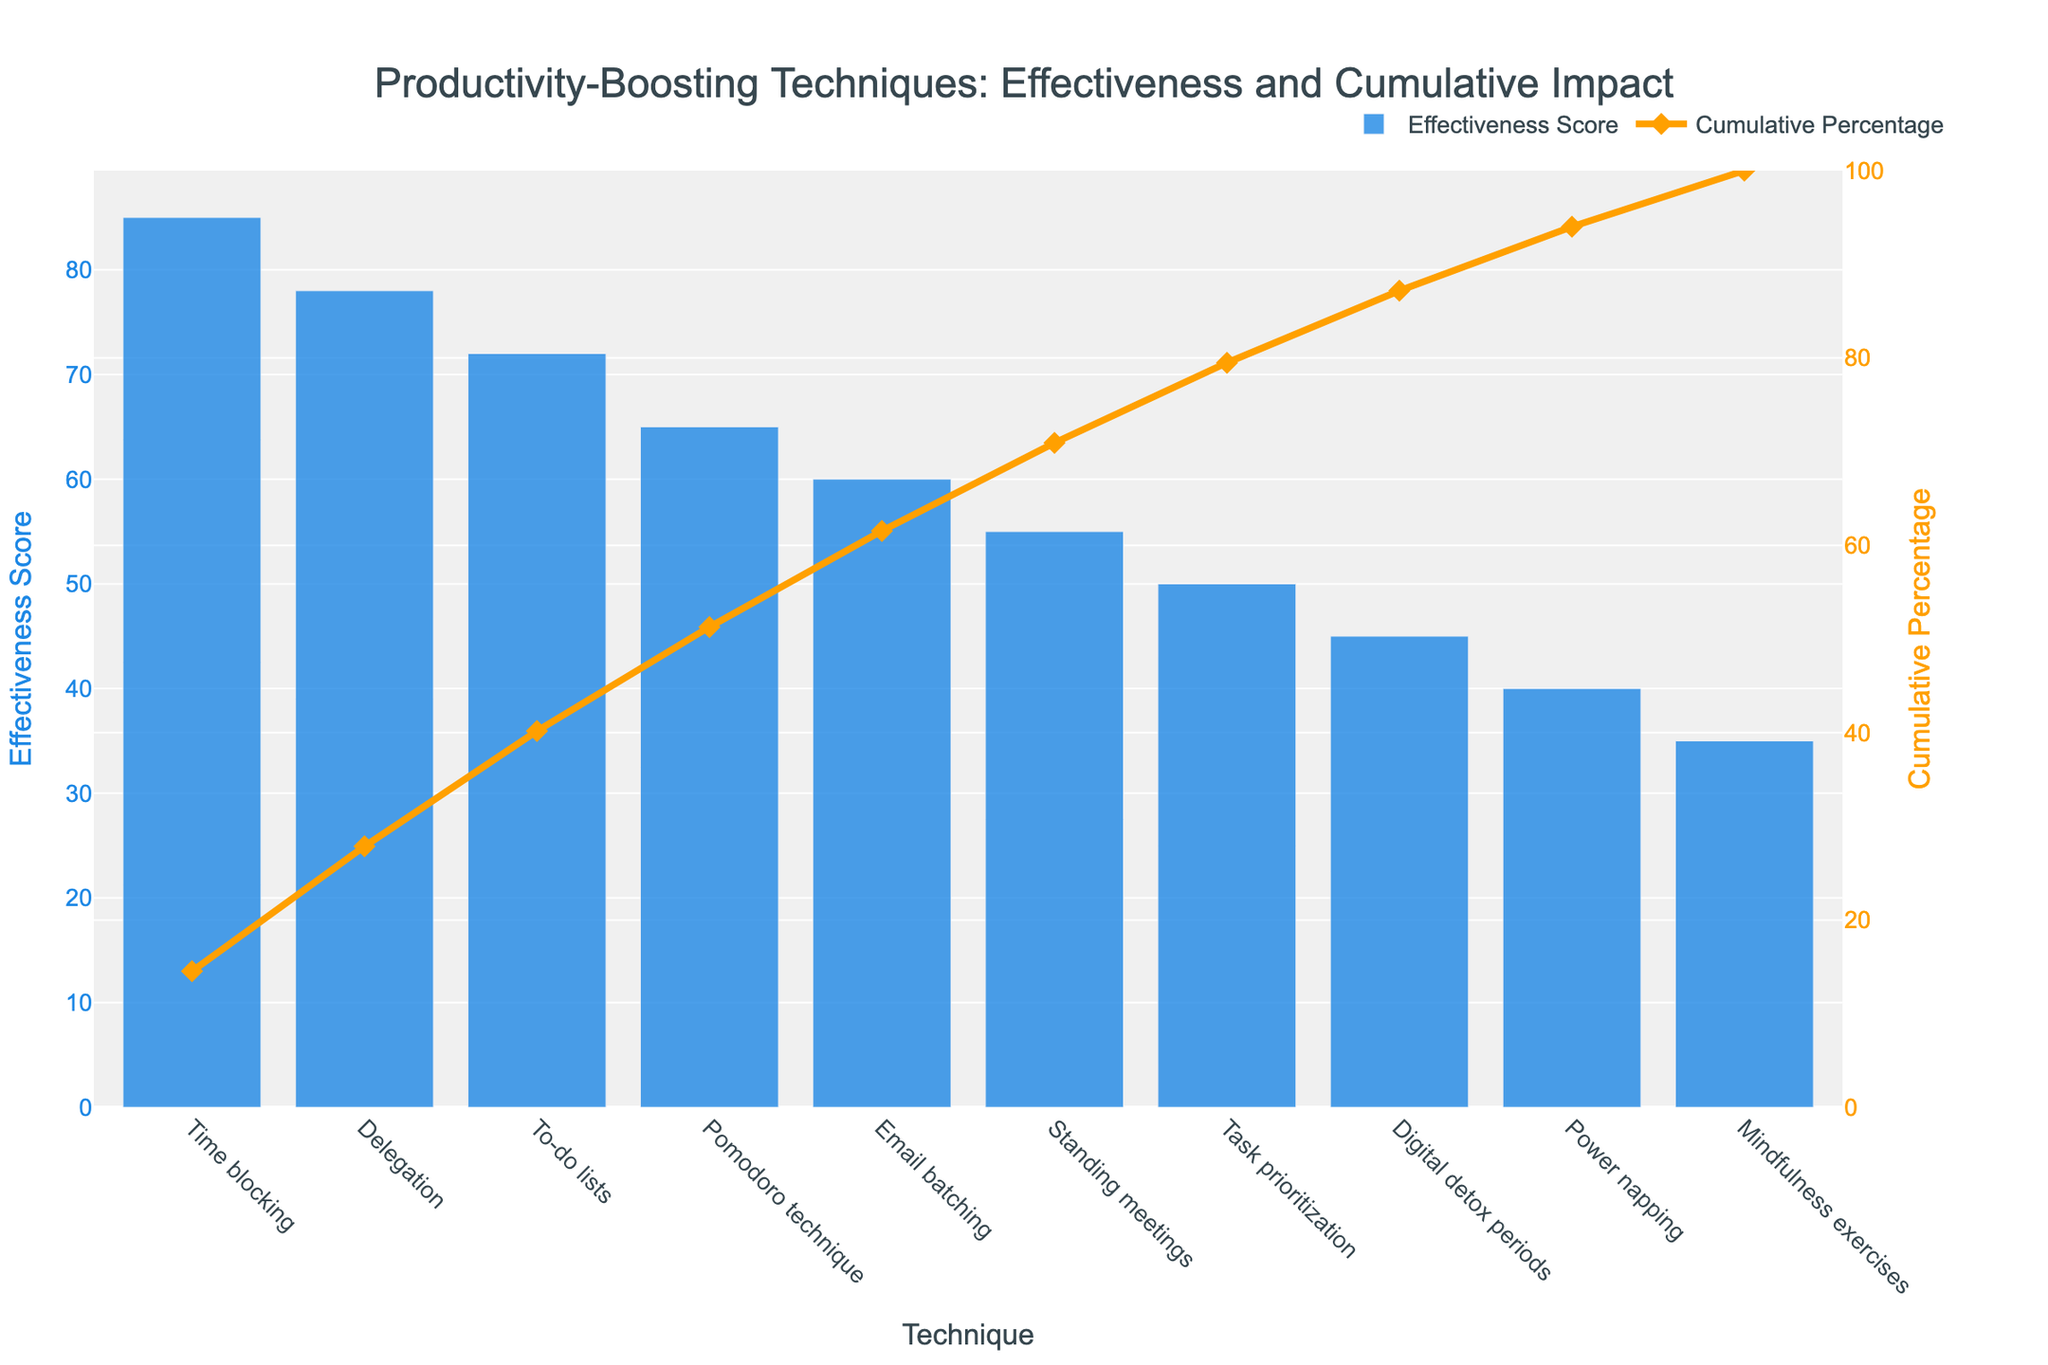What is the title of the chart? The title is located at the top center of the chart and appears in a larger font size compared to the other text elements. It is styled to attract attention and provide an overview of the data presented.
Answer: Productivity-Boosting Techniques: Effectiveness and Cumulative Impact How many productivity-boosting techniques are displayed in the chart? By counting the number of unique bars in the bar chart part of the Pareto chart, you can determine the number of techniques included.
Answer: 10 Which technique has the highest effectiveness score? The bar that reaches the highest point on the y-axis represents the technique with the highest effectiveness score. It will be the first bar in the chart.
Answer: Time blocking What is the effectiveness score of the Pomodoro technique? Look at the height of the corresponding bar for the Pomodoro technique and match it with the y-axis label to find the exact score.
Answer: 65 What is the cumulative percentage when Delegation is included? The cumulative percentage line intersects with Delegation on the x-axis. Trace this intersection to the right y-axis to find the cumulative percentage value.
Answer: Approximately 46.8% How much higher is the effectiveness score of Time blocking compared to Digital detox periods? Find the effectiveness scores for both Time blocking and Digital detox periods, then subtract the latter from the former.
Answer: 85 - 45 = 40 Which technique has a lower effectiveness score: Email batching or Task prioritization? Compare the heights of the bars for Email batching and Task prioritization. The shorter bar represents the technique with the lower effectiveness score.
Answer: Task prioritization At what cumulative percentage do both Power napping and Mindfulness exercises fall below? Identify the data points for Power napping and Mindfulness exercises on the cumulative percentage line and find them on the right y-axis. Both should fall just below a certain percentage.
Answer: Below 71.8% What is the color used for the bar representing effectiveness scores? Observe the color fill of the bars in the chart. This color is consistent across all bars representing effectiveness scores.
Answer: Blue (specifically a shade similar to '#1E88E5') What is the difference in cumulative percentage from the first to the last technique on the chart? Determine the cumulative percentage for Time blocking (first technique) and Mindfulness exercises (last technique), then find the difference.
Answer: 100% - 14.4% = 85.6% 